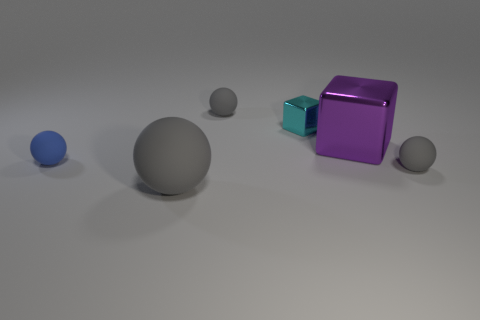The purple object that is made of the same material as the small cyan cube is what shape?
Provide a succinct answer. Cube. Are there any big purple metallic objects on the right side of the large gray thing?
Offer a terse response. Yes. Is the number of small things that are left of the big gray sphere less than the number of small matte balls?
Your answer should be compact. Yes. What is the tiny cyan thing made of?
Your response must be concise. Metal. What color is the big matte thing?
Your answer should be compact. Gray. There is a matte sphere that is both in front of the small blue sphere and behind the large rubber thing; what is its color?
Keep it short and to the point. Gray. Are the large gray ball and the gray sphere behind the tiny shiny cube made of the same material?
Ensure brevity in your answer.  Yes. There is a cyan block left of the big thing behind the large gray matte ball; what size is it?
Keep it short and to the point. Small. Are there any other things of the same color as the big matte ball?
Your answer should be very brief. Yes. Are the large thing that is right of the large matte ball and the small gray ball behind the small blue object made of the same material?
Provide a short and direct response. No. 